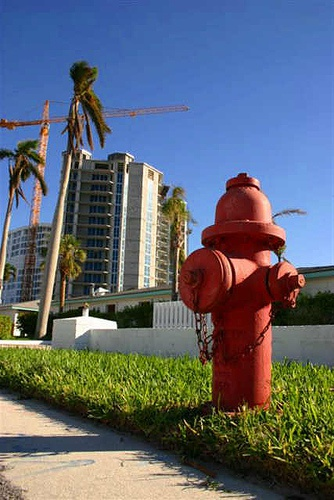Describe the objects in this image and their specific colors. I can see a fire hydrant in blue, maroon, black, and salmon tones in this image. 